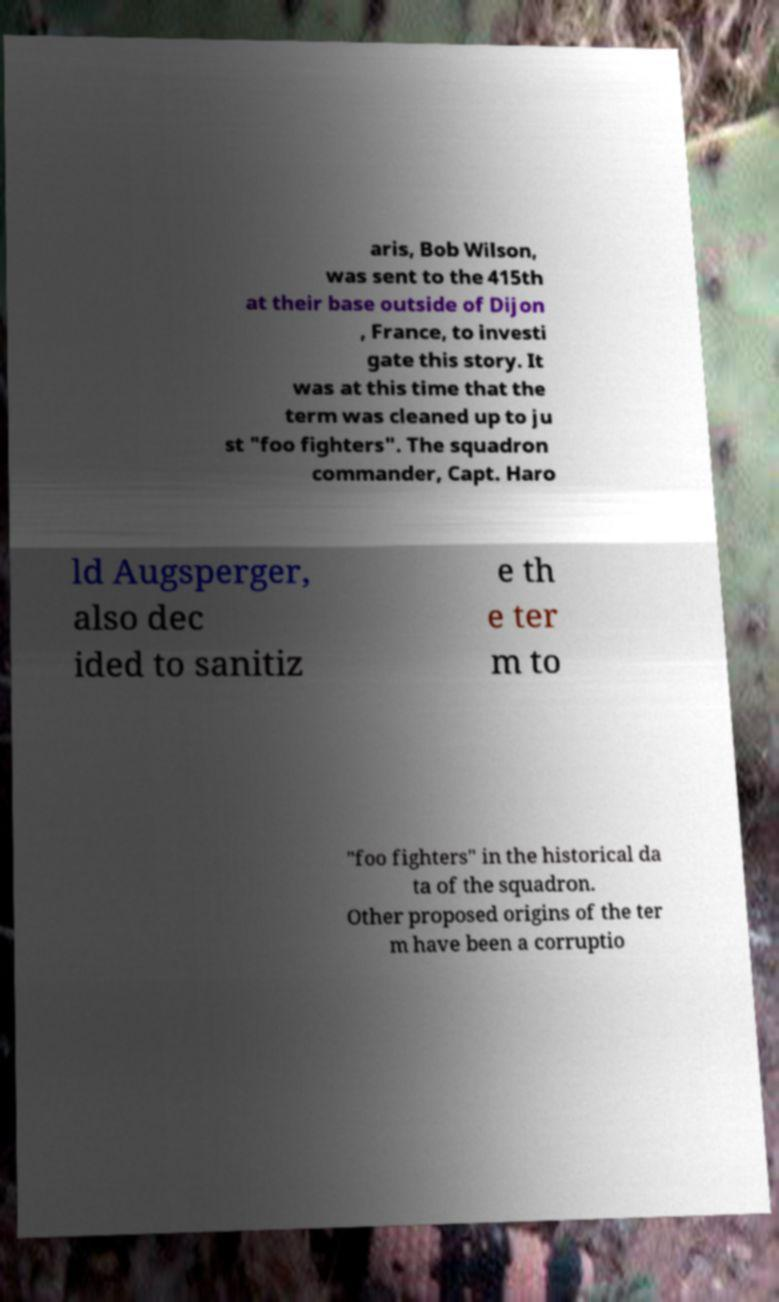I need the written content from this picture converted into text. Can you do that? aris, Bob Wilson, was sent to the 415th at their base outside of Dijon , France, to investi gate this story. It was at this time that the term was cleaned up to ju st "foo fighters". The squadron commander, Capt. Haro ld Augsperger, also dec ided to sanitiz e th e ter m to "foo fighters" in the historical da ta of the squadron. Other proposed origins of the ter m have been a corruptio 